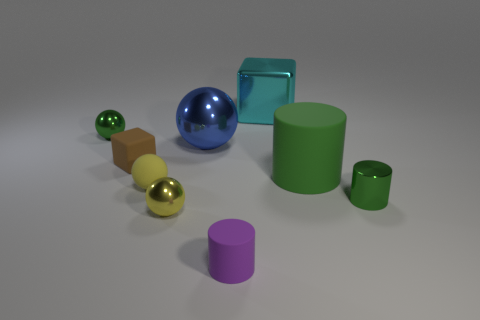Subtract all green spheres. How many spheres are left? 3 Subtract all gray balls. Subtract all red cylinders. How many balls are left? 4 Subtract all cylinders. How many objects are left? 6 Add 8 small yellow matte balls. How many small yellow matte balls are left? 9 Add 4 blue shiny spheres. How many blue shiny spheres exist? 5 Subtract 0 blue cylinders. How many objects are left? 9 Subtract all blue balls. Subtract all big metallic blocks. How many objects are left? 7 